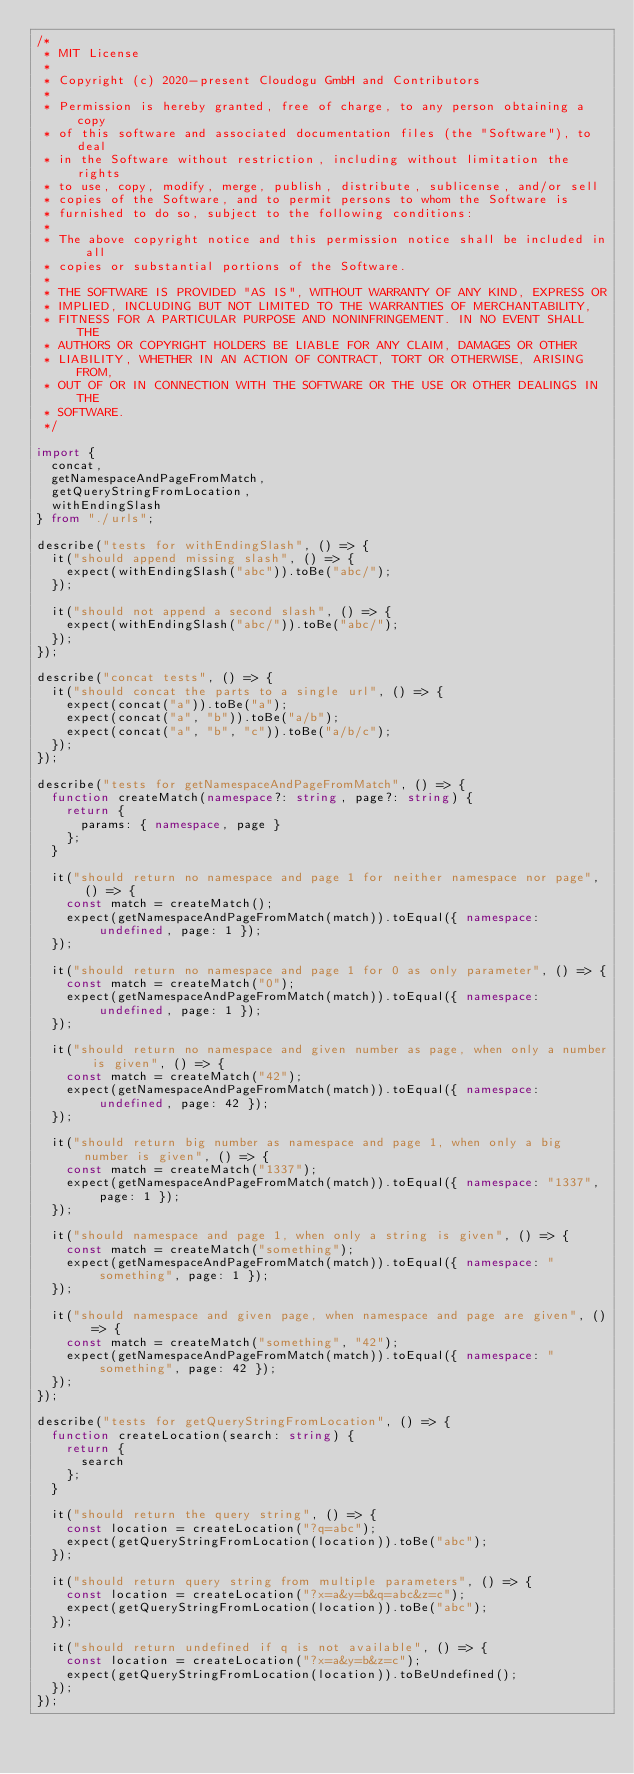Convert code to text. <code><loc_0><loc_0><loc_500><loc_500><_TypeScript_>/*
 * MIT License
 *
 * Copyright (c) 2020-present Cloudogu GmbH and Contributors
 *
 * Permission is hereby granted, free of charge, to any person obtaining a copy
 * of this software and associated documentation files (the "Software"), to deal
 * in the Software without restriction, including without limitation the rights
 * to use, copy, modify, merge, publish, distribute, sublicense, and/or sell
 * copies of the Software, and to permit persons to whom the Software is
 * furnished to do so, subject to the following conditions:
 *
 * The above copyright notice and this permission notice shall be included in all
 * copies or substantial portions of the Software.
 *
 * THE SOFTWARE IS PROVIDED "AS IS", WITHOUT WARRANTY OF ANY KIND, EXPRESS OR
 * IMPLIED, INCLUDING BUT NOT LIMITED TO THE WARRANTIES OF MERCHANTABILITY,
 * FITNESS FOR A PARTICULAR PURPOSE AND NONINFRINGEMENT. IN NO EVENT SHALL THE
 * AUTHORS OR COPYRIGHT HOLDERS BE LIABLE FOR ANY CLAIM, DAMAGES OR OTHER
 * LIABILITY, WHETHER IN AN ACTION OF CONTRACT, TORT OR OTHERWISE, ARISING FROM,
 * OUT OF OR IN CONNECTION WITH THE SOFTWARE OR THE USE OR OTHER DEALINGS IN THE
 * SOFTWARE.
 */

import {
  concat,
  getNamespaceAndPageFromMatch,
  getQueryStringFromLocation,
  withEndingSlash
} from "./urls";

describe("tests for withEndingSlash", () => {
  it("should append missing slash", () => {
    expect(withEndingSlash("abc")).toBe("abc/");
  });

  it("should not append a second slash", () => {
    expect(withEndingSlash("abc/")).toBe("abc/");
  });
});

describe("concat tests", () => {
  it("should concat the parts to a single url", () => {
    expect(concat("a")).toBe("a");
    expect(concat("a", "b")).toBe("a/b");
    expect(concat("a", "b", "c")).toBe("a/b/c");
  });
});

describe("tests for getNamespaceAndPageFromMatch", () => {
  function createMatch(namespace?: string, page?: string) {
    return {
      params: { namespace, page }
    };
  }

  it("should return no namespace and page 1 for neither namespace nor page", () => {
    const match = createMatch();
    expect(getNamespaceAndPageFromMatch(match)).toEqual({ namespace: undefined, page: 1 });
  });

  it("should return no namespace and page 1 for 0 as only parameter", () => {
    const match = createMatch("0");
    expect(getNamespaceAndPageFromMatch(match)).toEqual({ namespace: undefined, page: 1 });
  });

  it("should return no namespace and given number as page, when only a number is given", () => {
    const match = createMatch("42");
    expect(getNamespaceAndPageFromMatch(match)).toEqual({ namespace: undefined, page: 42 });
  });

  it("should return big number as namespace and page 1, when only a big number is given", () => {
    const match = createMatch("1337");
    expect(getNamespaceAndPageFromMatch(match)).toEqual({ namespace: "1337", page: 1 });
  });

  it("should namespace and page 1, when only a string is given", () => {
    const match = createMatch("something");
    expect(getNamespaceAndPageFromMatch(match)).toEqual({ namespace: "something", page: 1 });
  });

  it("should namespace and given page, when namespace and page are given", () => {
    const match = createMatch("something", "42");
    expect(getNamespaceAndPageFromMatch(match)).toEqual({ namespace: "something", page: 42 });
  });
});

describe("tests for getQueryStringFromLocation", () => {
  function createLocation(search: string) {
    return {
      search
    };
  }

  it("should return the query string", () => {
    const location = createLocation("?q=abc");
    expect(getQueryStringFromLocation(location)).toBe("abc");
  });

  it("should return query string from multiple parameters", () => {
    const location = createLocation("?x=a&y=b&q=abc&z=c");
    expect(getQueryStringFromLocation(location)).toBe("abc");
  });

  it("should return undefined if q is not available", () => {
    const location = createLocation("?x=a&y=b&z=c");
    expect(getQueryStringFromLocation(location)).toBeUndefined();
  });
});
</code> 